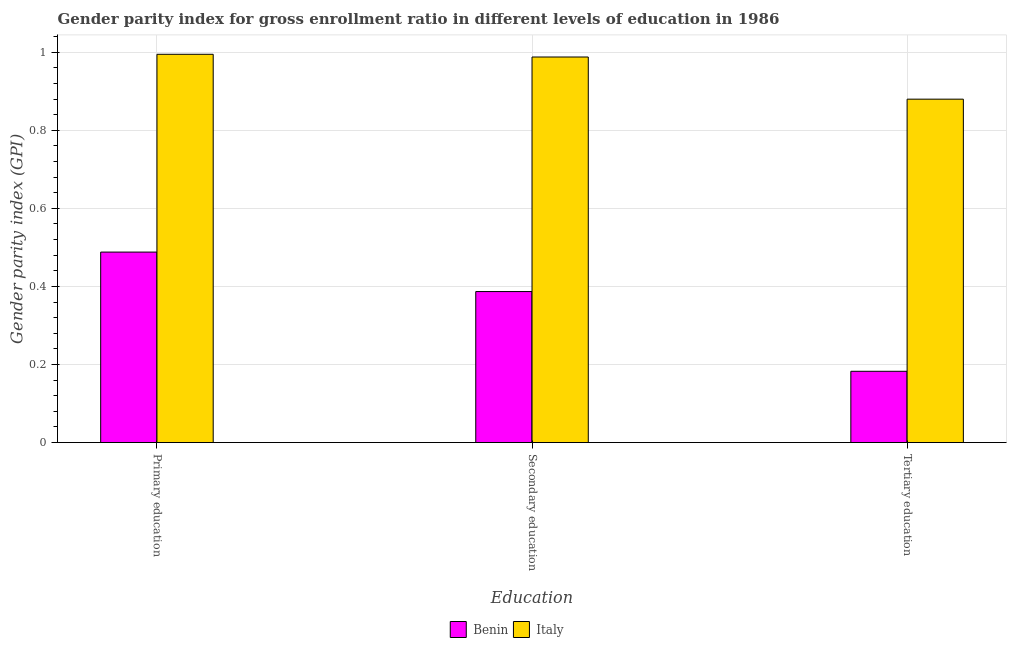How many different coloured bars are there?
Provide a short and direct response. 2. Are the number of bars per tick equal to the number of legend labels?
Your answer should be very brief. Yes. What is the label of the 3rd group of bars from the left?
Give a very brief answer. Tertiary education. What is the gender parity index in primary education in Italy?
Your answer should be very brief. 0.99. Across all countries, what is the maximum gender parity index in tertiary education?
Ensure brevity in your answer.  0.88. Across all countries, what is the minimum gender parity index in primary education?
Keep it short and to the point. 0.49. In which country was the gender parity index in tertiary education minimum?
Provide a short and direct response. Benin. What is the total gender parity index in secondary education in the graph?
Provide a short and direct response. 1.37. What is the difference between the gender parity index in tertiary education in Benin and that in Italy?
Your answer should be very brief. -0.7. What is the difference between the gender parity index in secondary education in Benin and the gender parity index in primary education in Italy?
Keep it short and to the point. -0.61. What is the average gender parity index in secondary education per country?
Your answer should be very brief. 0.69. What is the difference between the gender parity index in secondary education and gender parity index in primary education in Italy?
Ensure brevity in your answer.  -0.01. In how many countries, is the gender parity index in secondary education greater than 0.2 ?
Make the answer very short. 2. What is the ratio of the gender parity index in primary education in Benin to that in Italy?
Keep it short and to the point. 0.49. Is the gender parity index in secondary education in Italy less than that in Benin?
Provide a succinct answer. No. Is the difference between the gender parity index in secondary education in Benin and Italy greater than the difference between the gender parity index in primary education in Benin and Italy?
Provide a short and direct response. No. What is the difference between the highest and the second highest gender parity index in secondary education?
Provide a succinct answer. 0.6. What is the difference between the highest and the lowest gender parity index in secondary education?
Your answer should be compact. 0.6. Is the sum of the gender parity index in secondary education in Benin and Italy greater than the maximum gender parity index in primary education across all countries?
Give a very brief answer. Yes. What does the 2nd bar from the left in Primary education represents?
Your answer should be compact. Italy. What does the 2nd bar from the right in Primary education represents?
Give a very brief answer. Benin. Is it the case that in every country, the sum of the gender parity index in primary education and gender parity index in secondary education is greater than the gender parity index in tertiary education?
Keep it short and to the point. Yes. How many bars are there?
Your response must be concise. 6. How many countries are there in the graph?
Offer a terse response. 2. Are the values on the major ticks of Y-axis written in scientific E-notation?
Your answer should be very brief. No. Does the graph contain any zero values?
Provide a short and direct response. No. Does the graph contain grids?
Your answer should be compact. Yes. Where does the legend appear in the graph?
Your answer should be compact. Bottom center. How are the legend labels stacked?
Your response must be concise. Horizontal. What is the title of the graph?
Offer a terse response. Gender parity index for gross enrollment ratio in different levels of education in 1986. What is the label or title of the X-axis?
Your answer should be compact. Education. What is the label or title of the Y-axis?
Offer a very short reply. Gender parity index (GPI). What is the Gender parity index (GPI) in Benin in Primary education?
Provide a short and direct response. 0.49. What is the Gender parity index (GPI) in Italy in Primary education?
Your response must be concise. 0.99. What is the Gender parity index (GPI) in Benin in Secondary education?
Make the answer very short. 0.39. What is the Gender parity index (GPI) of Italy in Secondary education?
Make the answer very short. 0.99. What is the Gender parity index (GPI) of Benin in Tertiary education?
Your answer should be compact. 0.18. What is the Gender parity index (GPI) in Italy in Tertiary education?
Provide a short and direct response. 0.88. Across all Education, what is the maximum Gender parity index (GPI) of Benin?
Your answer should be compact. 0.49. Across all Education, what is the maximum Gender parity index (GPI) in Italy?
Your answer should be very brief. 0.99. Across all Education, what is the minimum Gender parity index (GPI) of Benin?
Ensure brevity in your answer.  0.18. Across all Education, what is the minimum Gender parity index (GPI) in Italy?
Your response must be concise. 0.88. What is the total Gender parity index (GPI) in Benin in the graph?
Keep it short and to the point. 1.06. What is the total Gender parity index (GPI) of Italy in the graph?
Offer a very short reply. 2.86. What is the difference between the Gender parity index (GPI) of Benin in Primary education and that in Secondary education?
Ensure brevity in your answer.  0.1. What is the difference between the Gender parity index (GPI) of Italy in Primary education and that in Secondary education?
Keep it short and to the point. 0.01. What is the difference between the Gender parity index (GPI) of Benin in Primary education and that in Tertiary education?
Offer a very short reply. 0.31. What is the difference between the Gender parity index (GPI) of Italy in Primary education and that in Tertiary education?
Offer a very short reply. 0.11. What is the difference between the Gender parity index (GPI) in Benin in Secondary education and that in Tertiary education?
Your answer should be very brief. 0.2. What is the difference between the Gender parity index (GPI) of Italy in Secondary education and that in Tertiary education?
Offer a very short reply. 0.11. What is the difference between the Gender parity index (GPI) of Benin in Primary education and the Gender parity index (GPI) of Italy in Secondary education?
Your answer should be compact. -0.5. What is the difference between the Gender parity index (GPI) of Benin in Primary education and the Gender parity index (GPI) of Italy in Tertiary education?
Keep it short and to the point. -0.39. What is the difference between the Gender parity index (GPI) in Benin in Secondary education and the Gender parity index (GPI) in Italy in Tertiary education?
Your answer should be compact. -0.49. What is the average Gender parity index (GPI) in Benin per Education?
Your response must be concise. 0.35. What is the average Gender parity index (GPI) in Italy per Education?
Provide a short and direct response. 0.95. What is the difference between the Gender parity index (GPI) in Benin and Gender parity index (GPI) in Italy in Primary education?
Your answer should be very brief. -0.51. What is the difference between the Gender parity index (GPI) in Benin and Gender parity index (GPI) in Italy in Secondary education?
Your answer should be compact. -0.6. What is the difference between the Gender parity index (GPI) of Benin and Gender parity index (GPI) of Italy in Tertiary education?
Give a very brief answer. -0.7. What is the ratio of the Gender parity index (GPI) in Benin in Primary education to that in Secondary education?
Offer a terse response. 1.26. What is the ratio of the Gender parity index (GPI) of Italy in Primary education to that in Secondary education?
Your response must be concise. 1.01. What is the ratio of the Gender parity index (GPI) of Benin in Primary education to that in Tertiary education?
Offer a terse response. 2.67. What is the ratio of the Gender parity index (GPI) in Italy in Primary education to that in Tertiary education?
Offer a very short reply. 1.13. What is the ratio of the Gender parity index (GPI) of Benin in Secondary education to that in Tertiary education?
Provide a succinct answer. 2.12. What is the ratio of the Gender parity index (GPI) of Italy in Secondary education to that in Tertiary education?
Provide a short and direct response. 1.12. What is the difference between the highest and the second highest Gender parity index (GPI) in Benin?
Your answer should be very brief. 0.1. What is the difference between the highest and the second highest Gender parity index (GPI) in Italy?
Give a very brief answer. 0.01. What is the difference between the highest and the lowest Gender parity index (GPI) of Benin?
Give a very brief answer. 0.31. What is the difference between the highest and the lowest Gender parity index (GPI) of Italy?
Give a very brief answer. 0.11. 